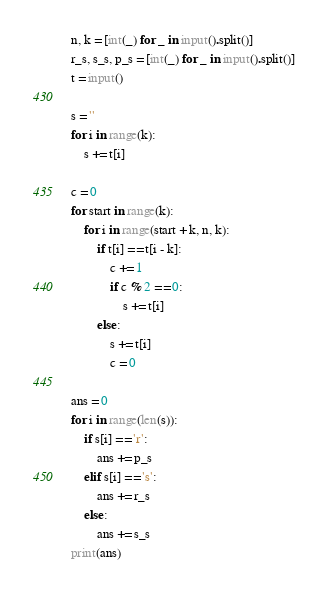Convert code to text. <code><loc_0><loc_0><loc_500><loc_500><_Python_>n, k = [int(_) for _ in input().split()]
r_s, s_s, p_s = [int(_) for _ in input().split()]
t = input()

s = ''
for i in range(k):
    s += t[i]

c = 0
for start in range(k):
    for i in range(start + k, n, k):
        if t[i] == t[i - k]:
            c += 1
            if c % 2 == 0:
                s += t[i]
        else:
            s += t[i]
            c = 0

ans = 0
for i in range(len(s)):
    if s[i] == 'r':
        ans += p_s
    elif s[i] == 's':
        ans += r_s
    else:
        ans += s_s
print(ans)</code> 